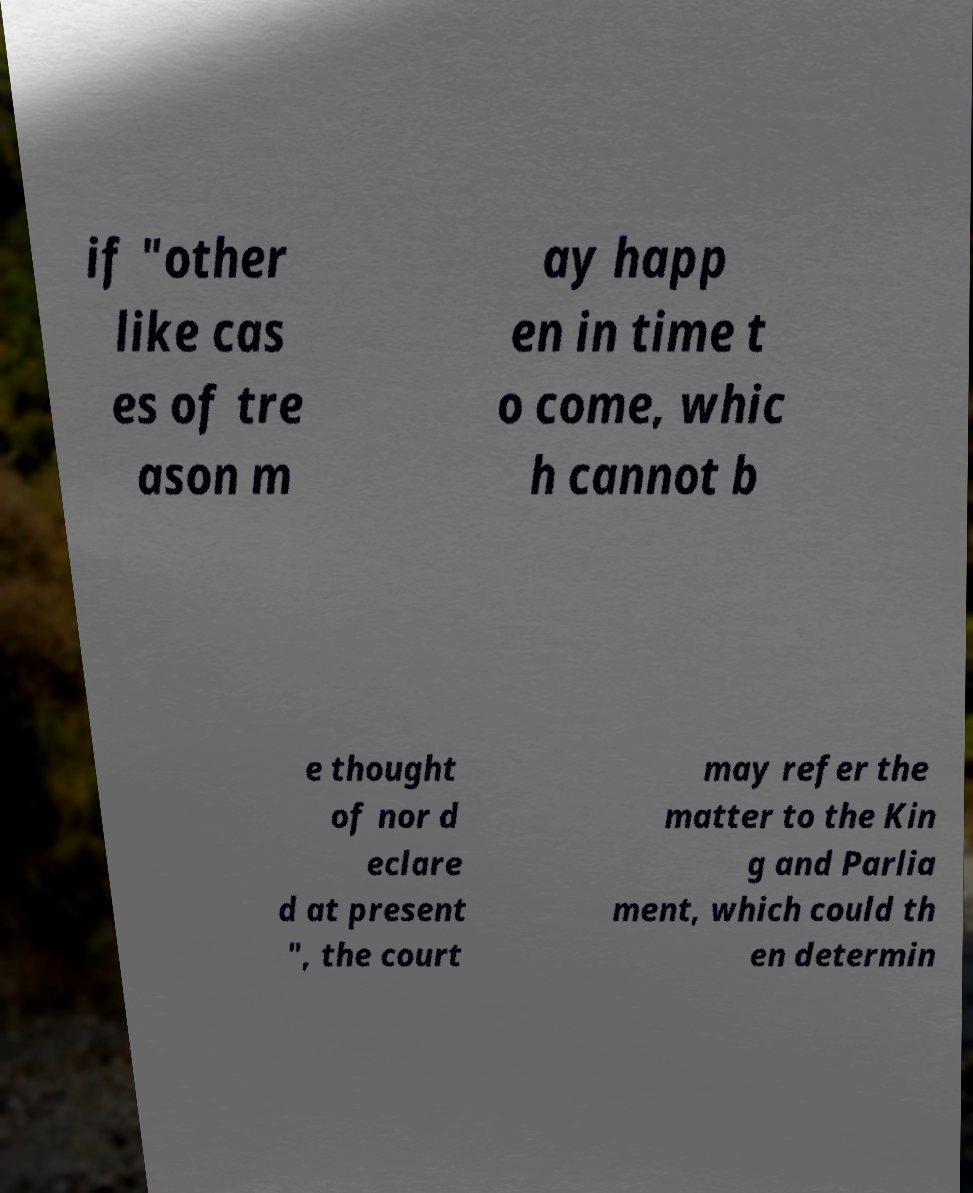Please identify and transcribe the text found in this image. if "other like cas es of tre ason m ay happ en in time t o come, whic h cannot b e thought of nor d eclare d at present ", the court may refer the matter to the Kin g and Parlia ment, which could th en determin 